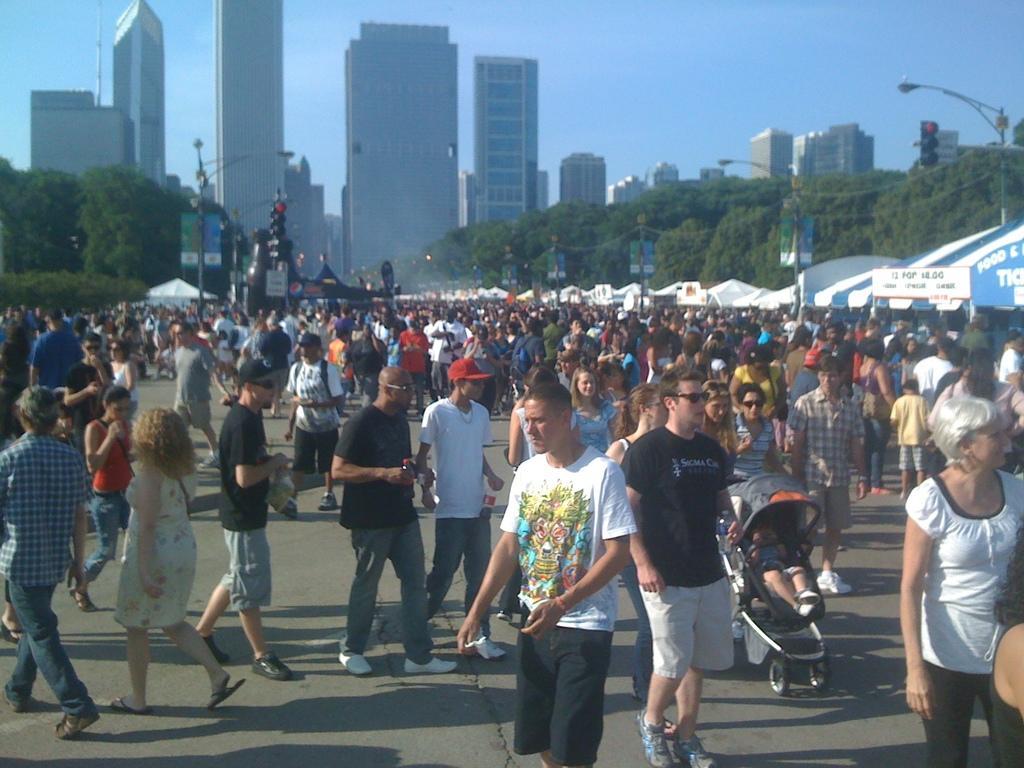Can you describe this image briefly? In this image there are lot of crowd, in the lift side and right side there are trees in the background there are buildings and a blue sky. 